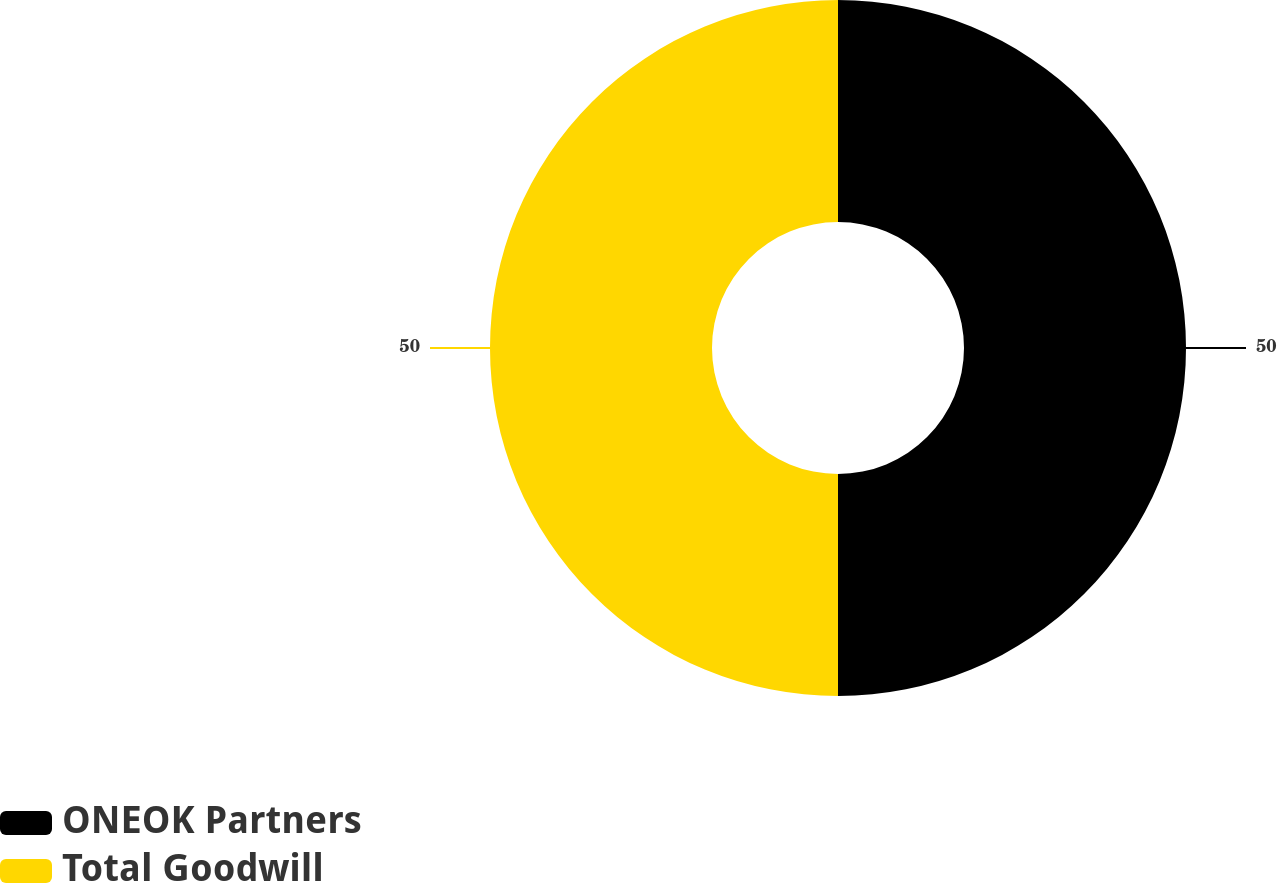<chart> <loc_0><loc_0><loc_500><loc_500><pie_chart><fcel>ONEOK Partners<fcel>Total Goodwill<nl><fcel>50.0%<fcel>50.0%<nl></chart> 